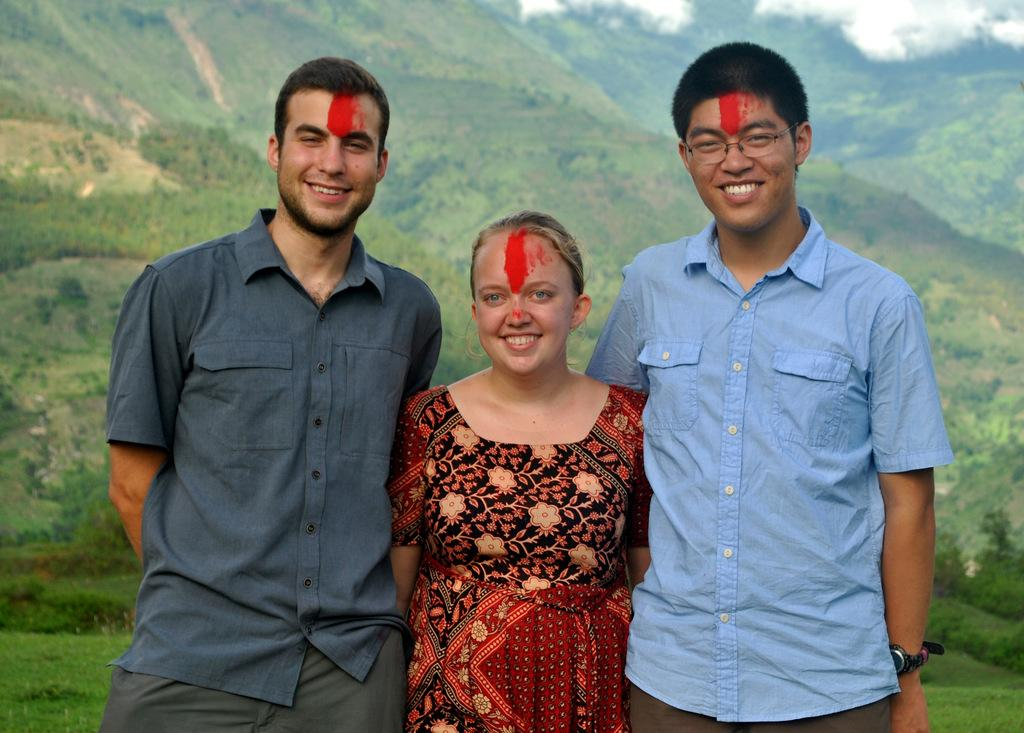How many people are visible in the image? There are three people standing in the front of the image. What are the people doing in the image? The people are smiling. What can be seen in the background of the image? There are clouds, trees, and grass in the background of the image. What type of dress is the person in the middle wearing in the image? There is no information about the clothing of the people in the image, so we cannot determine the type of dress the person in the middle is wearing. 